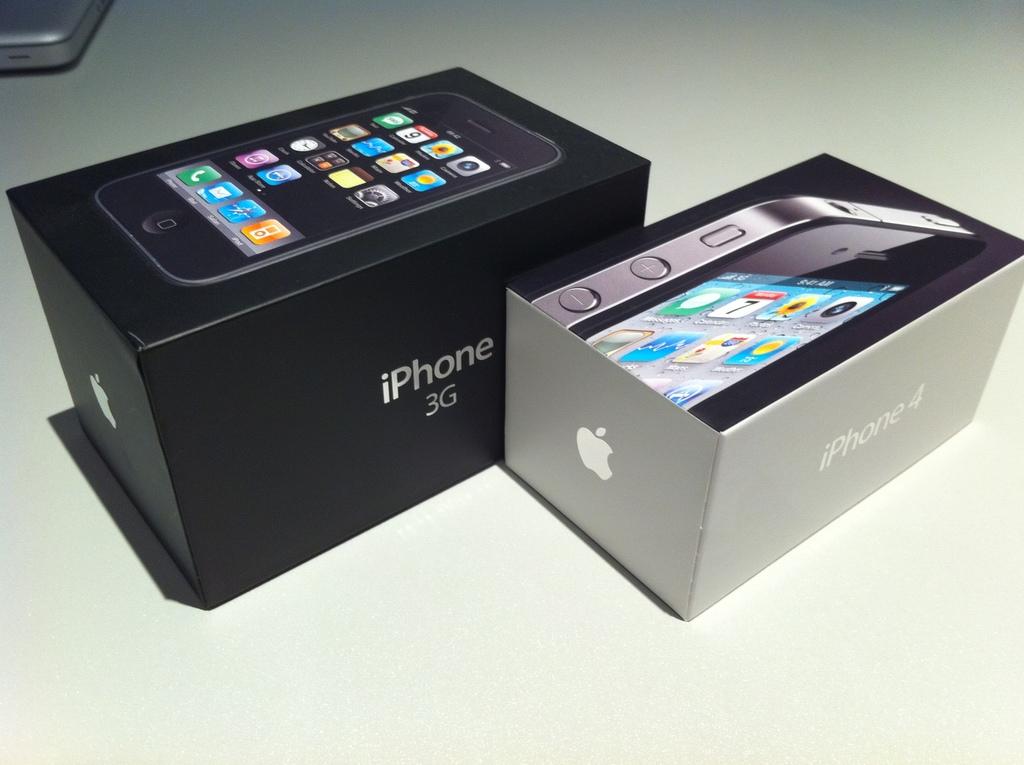What model is the phone in the black box?
Provide a short and direct response. Iphone 3g. What is inside of these boxes?
Provide a short and direct response. Iphone. 